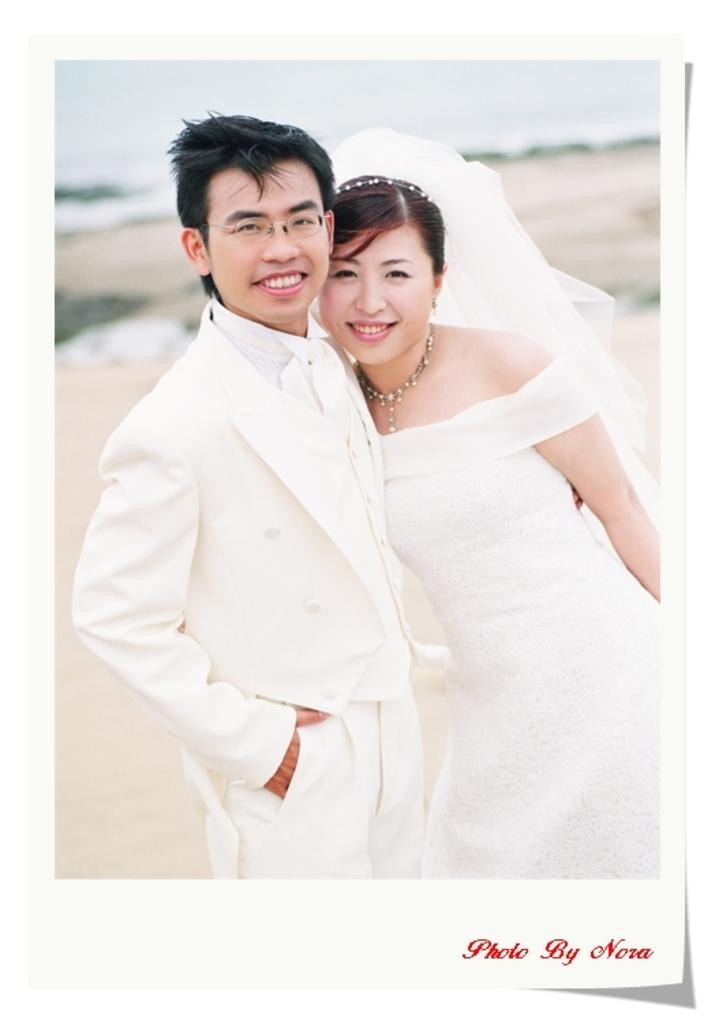Who is present in the image? There is a couple in the image. What is the facial expression of the couple? Both individuals in the couple are smiling. Is there any text in the image? Yes, there is some text in the bottom right side of the image. How would you describe the background of the image? The background of the image is blurred. What type of coil is being used by the band in the image? There is no band or coil present in the image; it features a couple smiling at each other. 